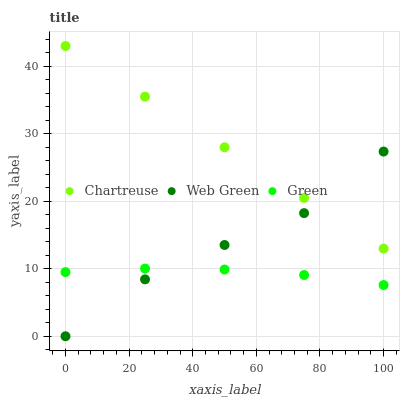Does Green have the minimum area under the curve?
Answer yes or no. Yes. Does Chartreuse have the maximum area under the curve?
Answer yes or no. Yes. Does Web Green have the minimum area under the curve?
Answer yes or no. No. Does Web Green have the maximum area under the curve?
Answer yes or no. No. Is Chartreuse the smoothest?
Answer yes or no. Yes. Is Web Green the roughest?
Answer yes or no. Yes. Is Green the smoothest?
Answer yes or no. No. Is Green the roughest?
Answer yes or no. No. Does Web Green have the lowest value?
Answer yes or no. Yes. Does Green have the lowest value?
Answer yes or no. No. Does Chartreuse have the highest value?
Answer yes or no. Yes. Does Web Green have the highest value?
Answer yes or no. No. Is Green less than Chartreuse?
Answer yes or no. Yes. Is Chartreuse greater than Green?
Answer yes or no. Yes. Does Green intersect Web Green?
Answer yes or no. Yes. Is Green less than Web Green?
Answer yes or no. No. Is Green greater than Web Green?
Answer yes or no. No. Does Green intersect Chartreuse?
Answer yes or no. No. 